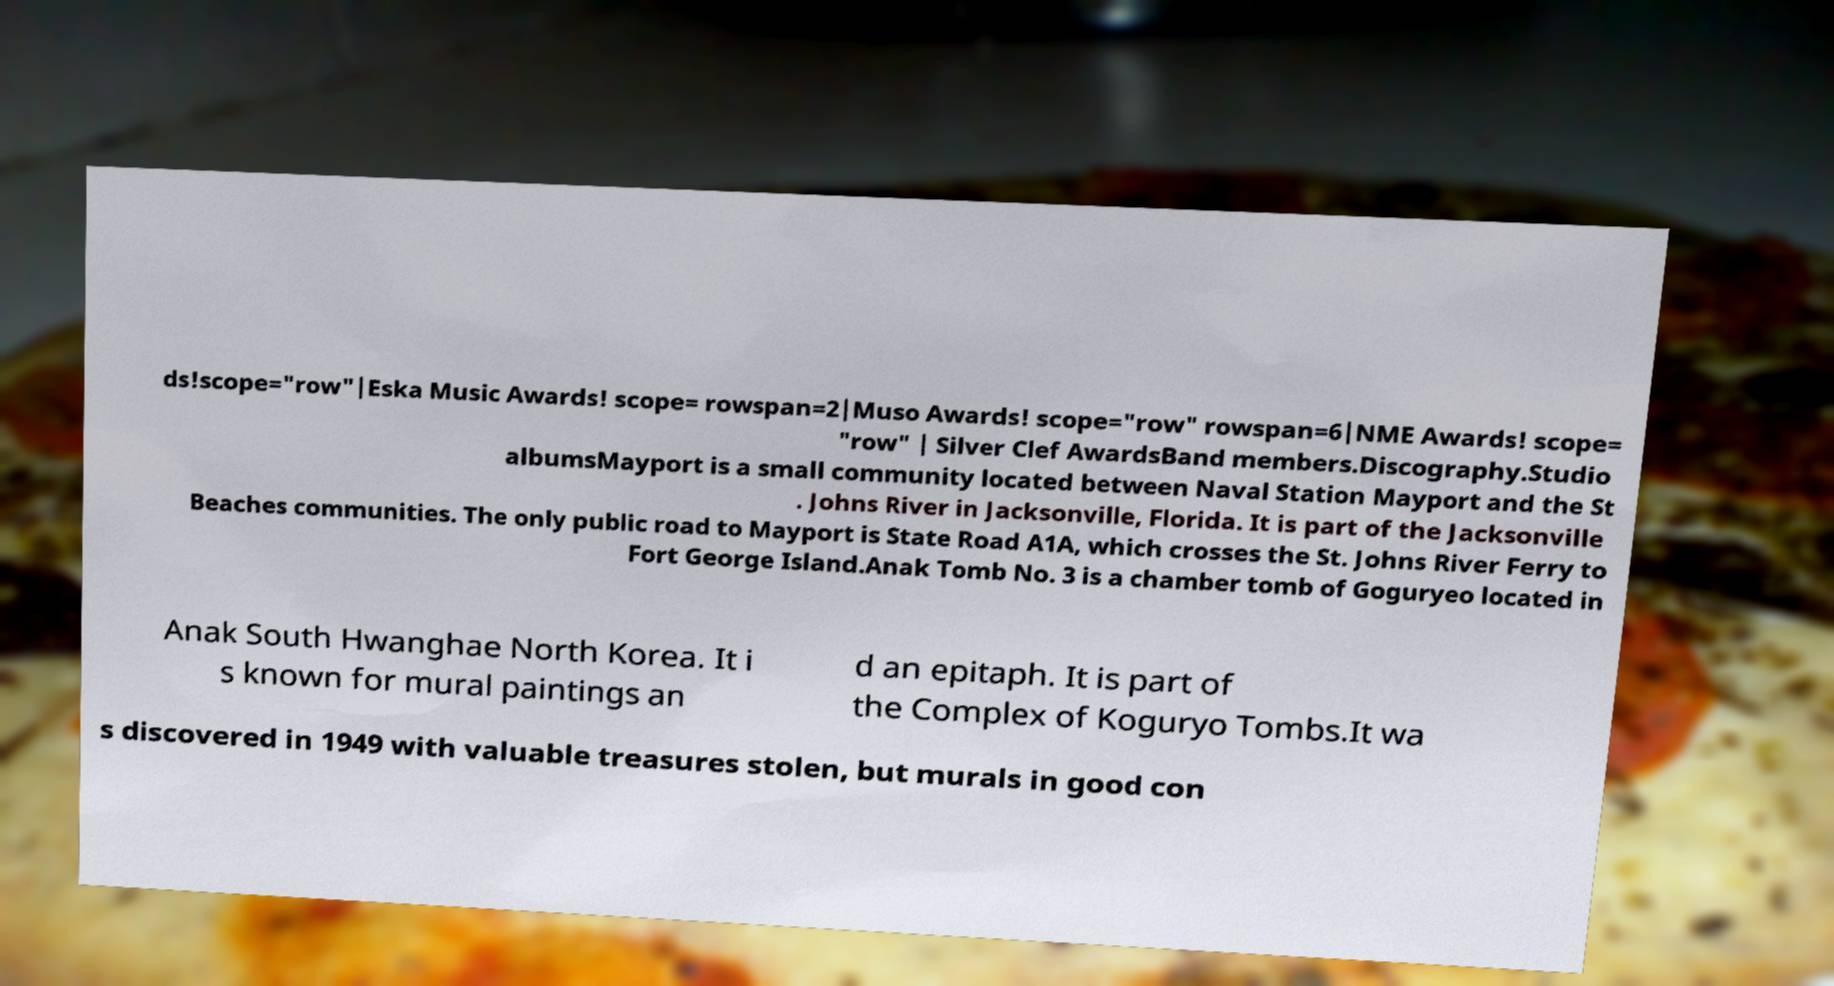For documentation purposes, I need the text within this image transcribed. Could you provide that? ds!scope="row"|Eska Music Awards! scope= rowspan=2|Muso Awards! scope="row" rowspan=6|NME Awards! scope= "row" | Silver Clef AwardsBand members.Discography.Studio albumsMayport is a small community located between Naval Station Mayport and the St . Johns River in Jacksonville, Florida. It is part of the Jacksonville Beaches communities. The only public road to Mayport is State Road A1A, which crosses the St. Johns River Ferry to Fort George Island.Anak Tomb No. 3 is a chamber tomb of Goguryeo located in Anak South Hwanghae North Korea. It i s known for mural paintings an d an epitaph. It is part of the Complex of Koguryo Tombs.It wa s discovered in 1949 with valuable treasures stolen, but murals in good con 